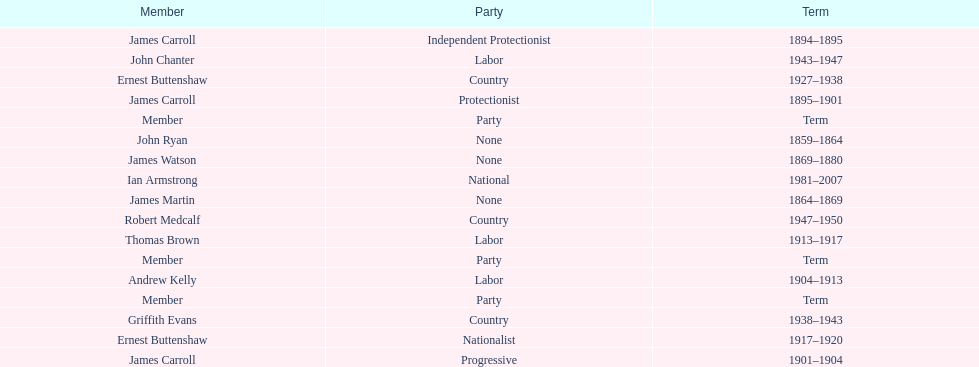How many years of service do the members of the second incarnation have combined? 26. 